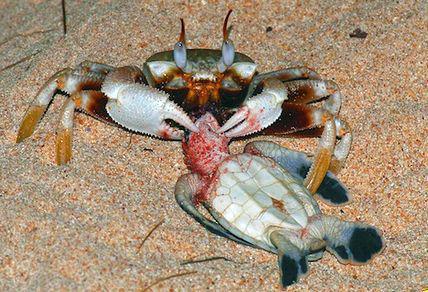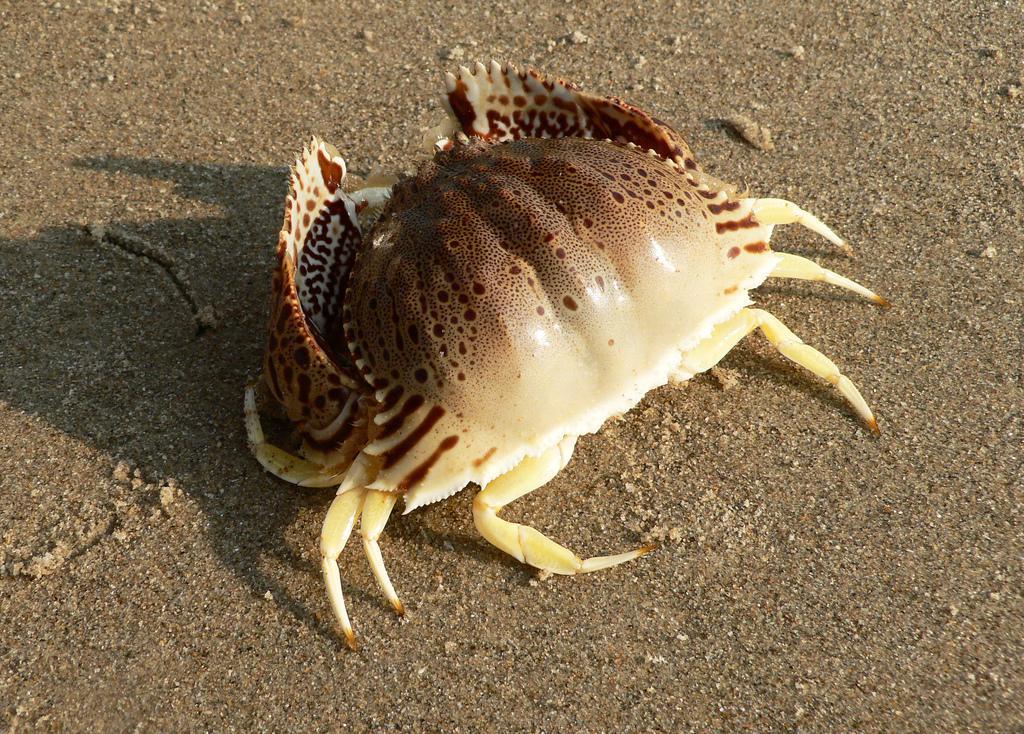The first image is the image on the left, the second image is the image on the right. Analyze the images presented: Is the assertion "All the crabs are on sand." valid? Answer yes or no. Yes. The first image is the image on the left, the second image is the image on the right. Examine the images to the left and right. Is the description "Each image contains one crab, and the crab on the left faces forward, while the crab on the right faces away from the camera." accurate? Answer yes or no. Yes. 